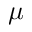Convert formula to latex. <formula><loc_0><loc_0><loc_500><loc_500>\mu</formula> 